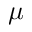Convert formula to latex. <formula><loc_0><loc_0><loc_500><loc_500>\mu</formula> 